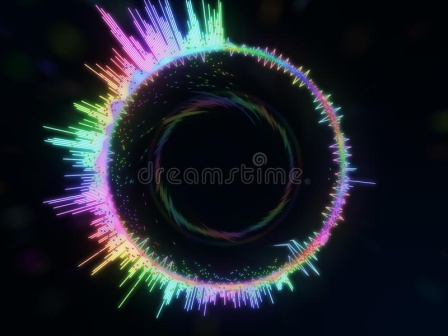Explain the visual content of the image in great detail. The image presents a captivating and mesmerizing depiction of what appears to be a stylized black hole, enveloped in a vibrant and colorful aura. At the center of the image, the black hole is set against a deep, pitch-black background, which dramatically highlights its presence. Surrounding the black hole is an intricate, circular aura formed by countless thin, radiant lines. These lines swirl and curve gracefully, creating a halo-like effect. The colors in this aura are vivid and varied, including shades of pink, blue, green, and yellow, blending seamlessly into one another. This blend of colors and the dynamic formation of lines give the image a surreal and dreamy quality, reminiscent of a cosmic phenomenon observed in the depths of space. The overall composition and use of colors create a sense of motion and depth, making the image both visually striking and deeply evocative. 